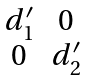Convert formula to latex. <formula><loc_0><loc_0><loc_500><loc_500>\begin{matrix} d ^ { \prime } _ { 1 } & 0 \\ 0 & d ^ { \prime } _ { 2 } \end{matrix}</formula> 